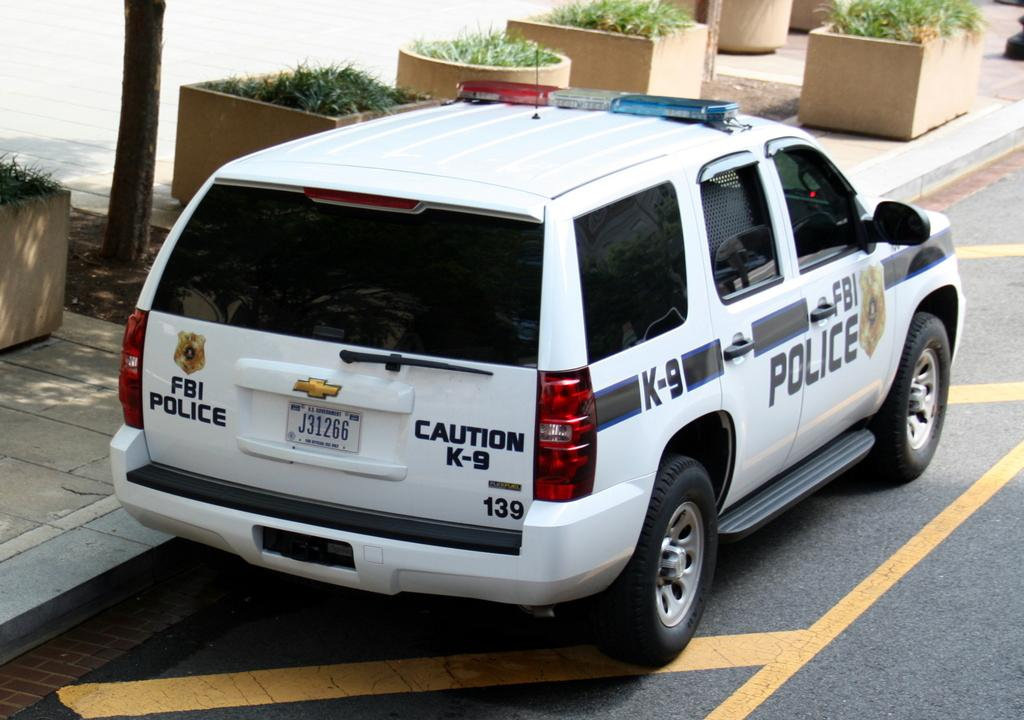What is parked on the road in the image? There is a car parked on the road in the image. What can be seen on the road in the image? There are yellow lines on the road in the image. What type of vegetation is visible in the background of the image? There are plants with pots in the background of the image. What type of path is visible in the background of the image? There is a walkway in the background of the image. What natural element is visible in the background of the image? There is a tree trunk in the background of the image. Where is the gun hidden in the image? There is no gun present in the image. What type of feather can be seen on the car in the image? There are no feathers visible on the car in the image. 